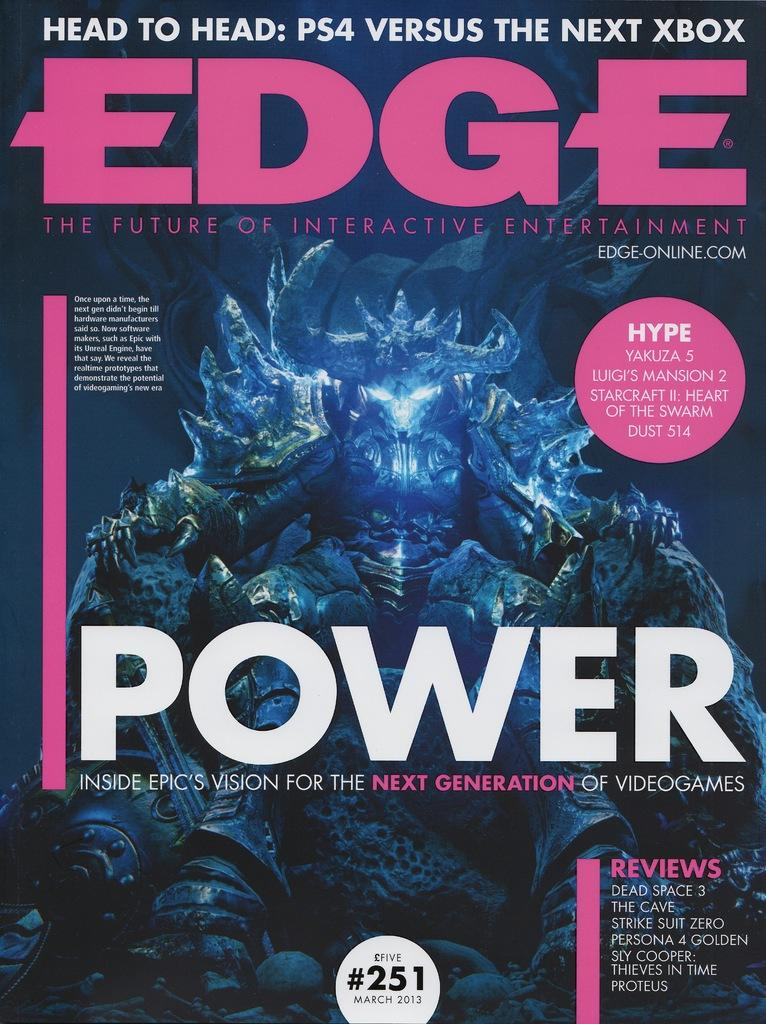What is present in the image? There is a poster in the image. What can be seen on the poster? The poster contains an animated image. How many rats are depicted on the poster? There is no mention of rats in the image or the provided facts, so we cannot determine the presence or number of rats on the poster. 